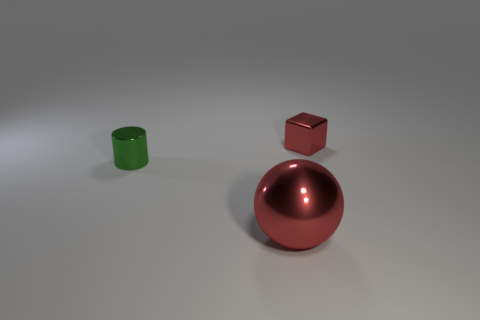Add 2 big red metal objects. How many objects exist? 5 Subtract 1 cylinders. How many cylinders are left? 0 Subtract all cyan metallic cylinders. Subtract all tiny cylinders. How many objects are left? 2 Add 1 cylinders. How many cylinders are left? 2 Add 2 large cyan matte cubes. How many large cyan matte cubes exist? 2 Subtract 0 gray spheres. How many objects are left? 3 Subtract all gray cylinders. Subtract all green balls. How many cylinders are left? 1 